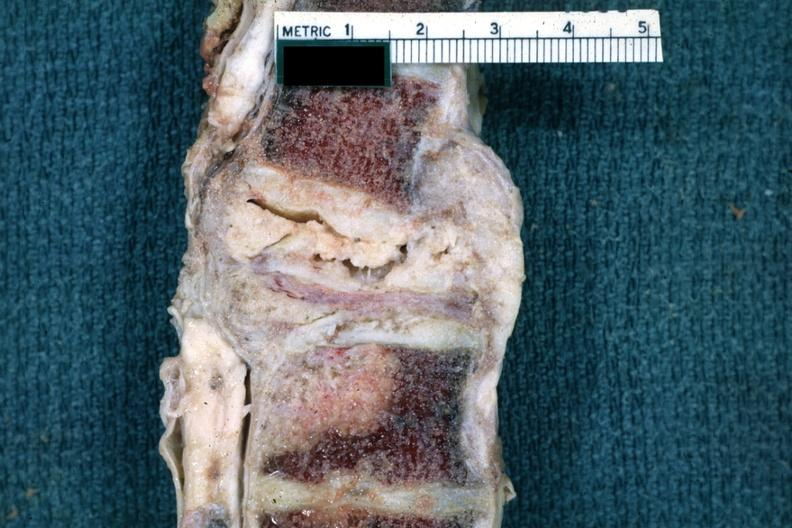what is present?
Answer the question using a single word or phrase. Joints 